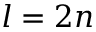Convert formula to latex. <formula><loc_0><loc_0><loc_500><loc_500>l = 2 n</formula> 